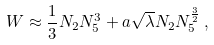Convert formula to latex. <formula><loc_0><loc_0><loc_500><loc_500>W \approx \frac { 1 } { 3 } N _ { 2 } N _ { 5 } ^ { 3 } + a \sqrt { \lambda } N _ { 2 } N _ { 5 } ^ { \frac { 3 } { 2 } } \, ,</formula> 